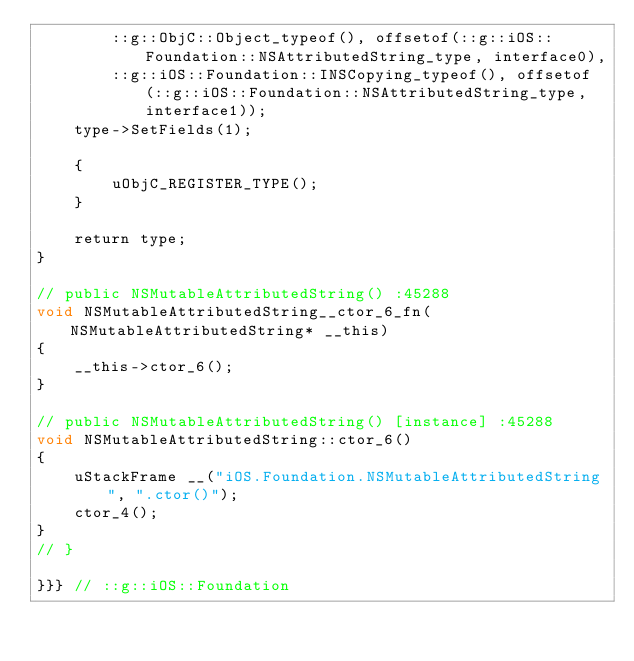<code> <loc_0><loc_0><loc_500><loc_500><_ObjectiveC_>        ::g::ObjC::Object_typeof(), offsetof(::g::iOS::Foundation::NSAttributedString_type, interface0),
        ::g::iOS::Foundation::INSCopying_typeof(), offsetof(::g::iOS::Foundation::NSAttributedString_type, interface1));
    type->SetFields(1);

    {
        uObjC_REGISTER_TYPE();
    }

    return type;
}

// public NSMutableAttributedString() :45288
void NSMutableAttributedString__ctor_6_fn(NSMutableAttributedString* __this)
{
    __this->ctor_6();
}

// public NSMutableAttributedString() [instance] :45288
void NSMutableAttributedString::ctor_6()
{
    uStackFrame __("iOS.Foundation.NSMutableAttributedString", ".ctor()");
    ctor_4();
}
// }

}}} // ::g::iOS::Foundation
</code> 